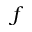<formula> <loc_0><loc_0><loc_500><loc_500>f</formula> 